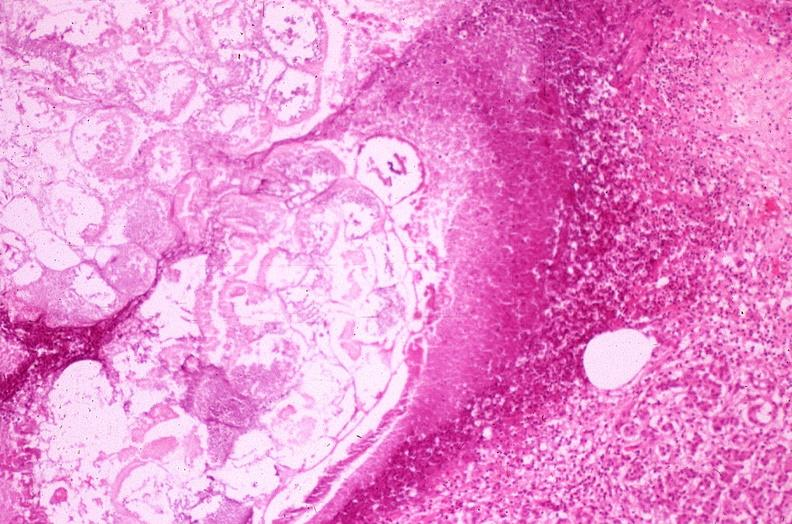does lesion show pancreatic fat necrosis?
Answer the question using a single word or phrase. No 